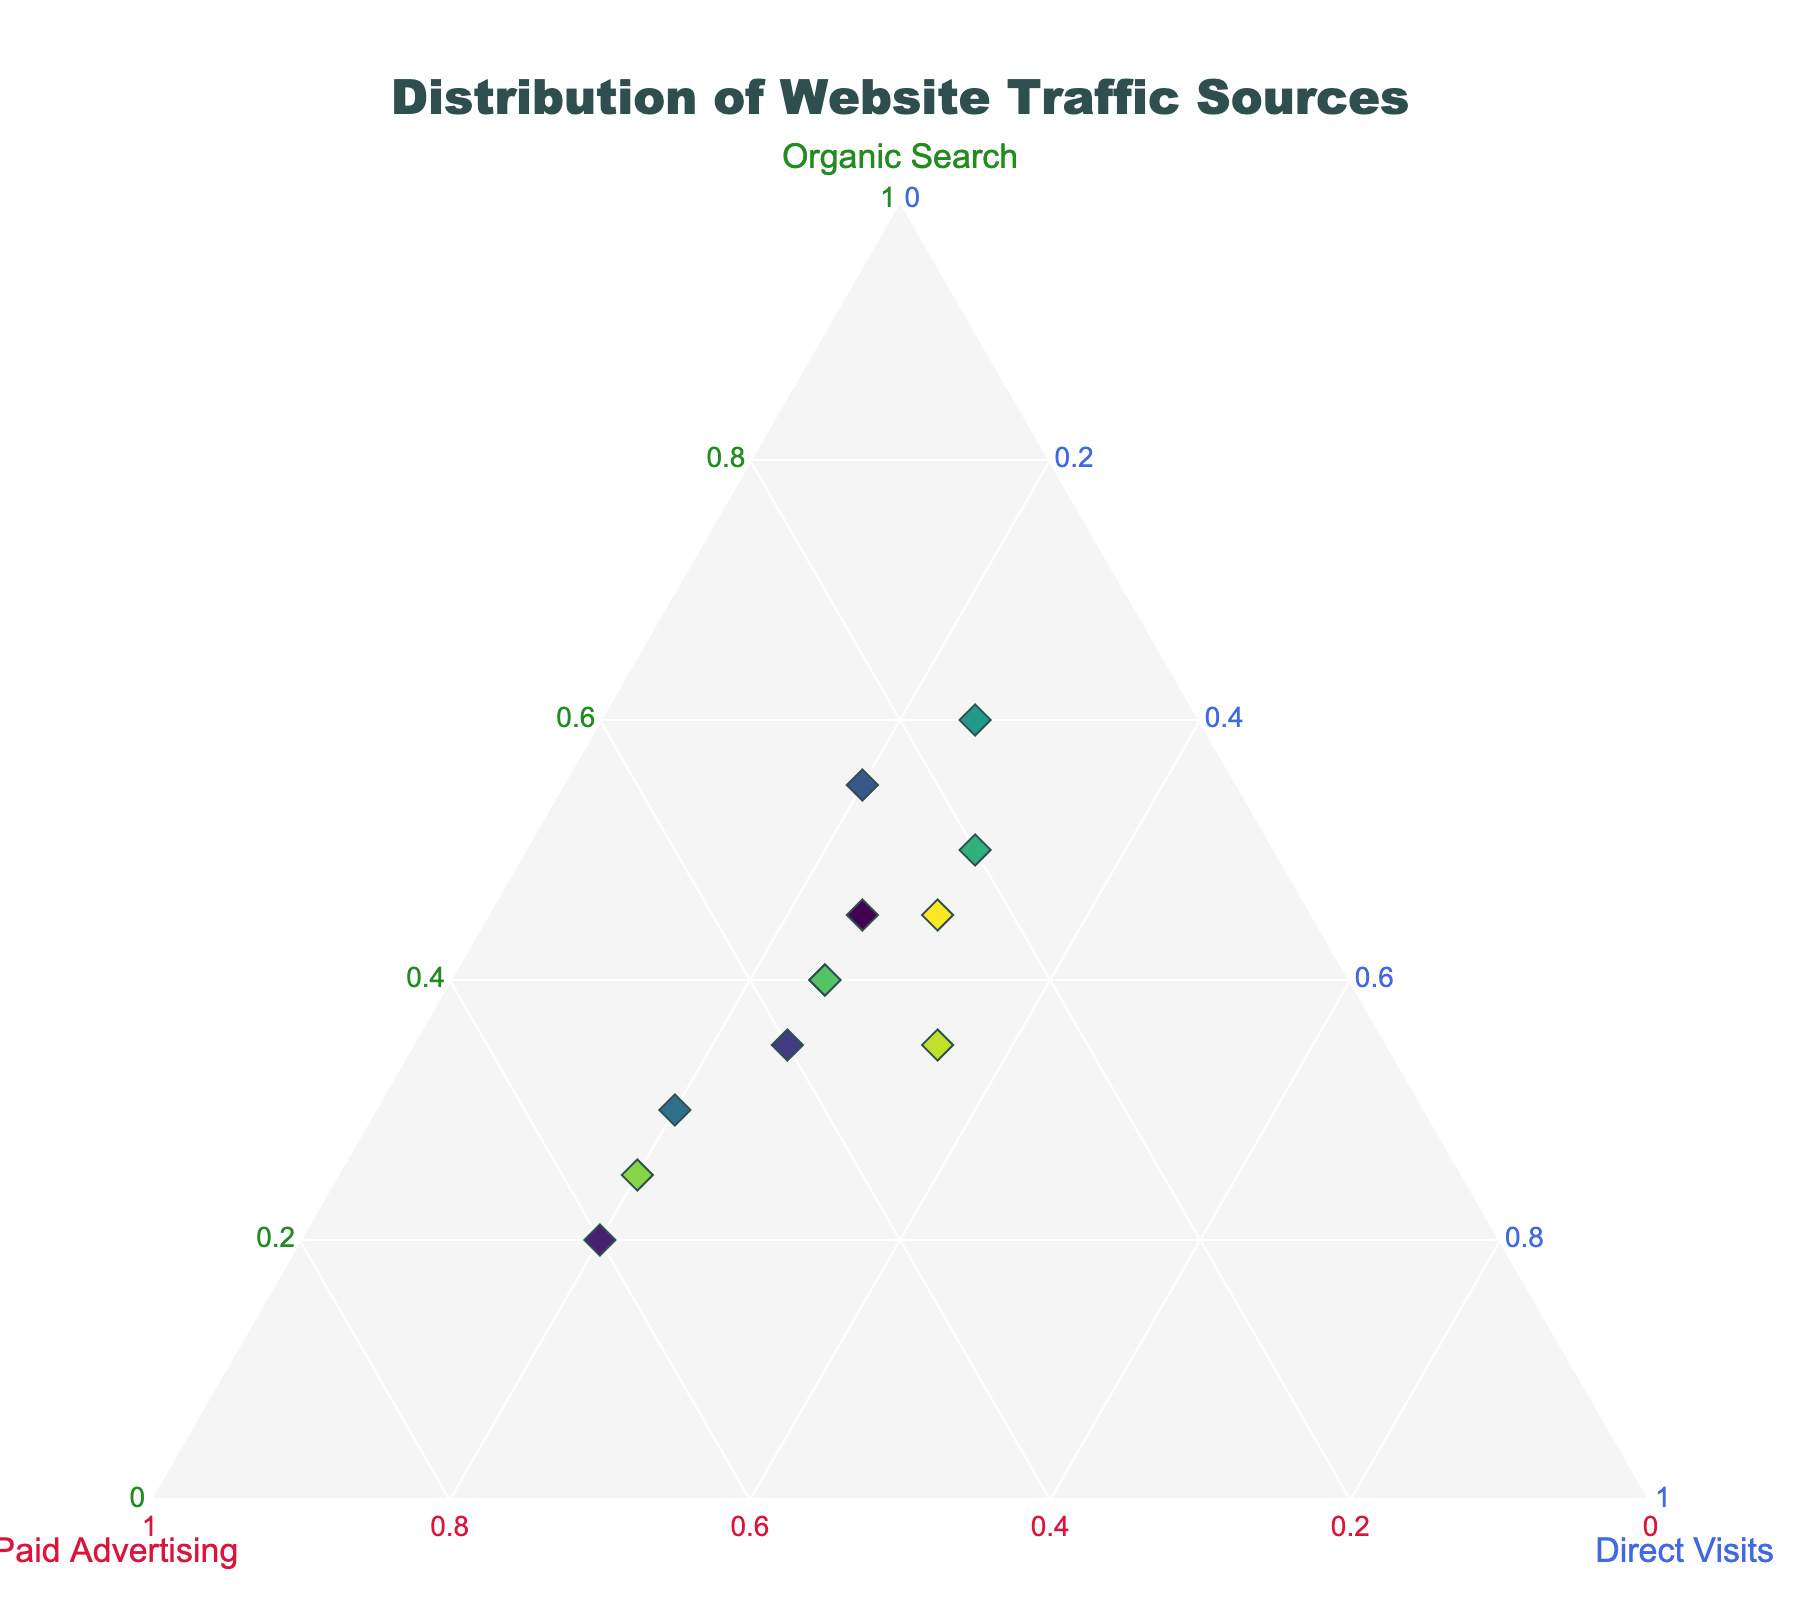What is the title of the figure? The title is usually displayed at the top of the figure, and it is explicitly stated in the Ternary Plot.
Answer: Distribution of Website Traffic Sources Which campaign has the highest percentage of organic search traffic? Look for the point with the highest value on the 'Organic Search' axis. The 'Campaign Blog' has the highest organic search percentage of 60%.
Answer: Campaign Blog How many campaigns have an equal distribution of 25% direct visits? Count the data points where the 'Direct Visits' percentage is 25%. There are five such campaigns.
Answer: 5 What is the average percentage of paid advertising traffic across all campaigns? Sum the percentages for paid advertising from all campaigns and divide by the number of campaigns. (30+60+40+25+50+35+15+20+35+55+30+25)/12 = 35.833
Answer: 35.833 Which campaign has the highest proportion of paid advertising traffic? Find the highest value on the 'Paid Advertising' axis. The 'Facebook Page' has the highest paid advertising percentage of 60%.
Answer: Facebook Page Which source of traffic is most dominant for the majority of campaigns: organic search, paid advertising, or direct visits? Determine the most common highest value among the three traffic sources for all campaigns. Paid advertising is dominant in the majority with six instances.
Answer: Paid Advertising How does the traffic distribution for the ''Volunteer Sign-up Page'' compare to the ''Virtual Town Hall''? Compare the percentages of Organic Search, Paid Advertising, and Direct Visits for both campaigns. The Volunteer Sign-up Page has 45% Organic Search, 25% Paid Advertising, and 30% Direct Visits, while Virtual Town Hall has 35% Organic Search, 30% Paid Advertising, and 35% Direct Visits.
Answer: Volunteer Sign-up Page: 45% OS, 25% PA, 30% DV; Virtual Town Hall: 35% OS, 30% PA, 35% DV Which campaigns have the same traffic distribution? Check if any campaign data points have identical percentages across all three traffic sources. The 'LinkedIn Page' and 'Policy Platform Microsite' both have 40% Organic Search, 35% Paid Advertising, and 25% Direct Visits.
Answer: LinkedIn Page and Policy Platform Microsite What is the traffic distribution for the 'YouTube Channel'? Locate the data point for 'YouTube Channel' and read off the percentages for each source of traffic. The 'YouTube Channel' has 55% Organic Search, 25% Paid Advertising, and 20% Direct Visits.
Answer: 55% Organic Search, 25% Paid Advertising, 20% Direct Visits Which campaigns have a higher percentage of direct visits than organic search? Compare the 'Direct Visits' and 'Organic Search' for each campaign and find which ones have a higher value for 'Direct Visits'. 'Voter Registration Portal' and 'Virtual Town Hall' have higher Direct Visits than Organic Search.
Answer: Voter Registration Portal and Virtual Town Hall 